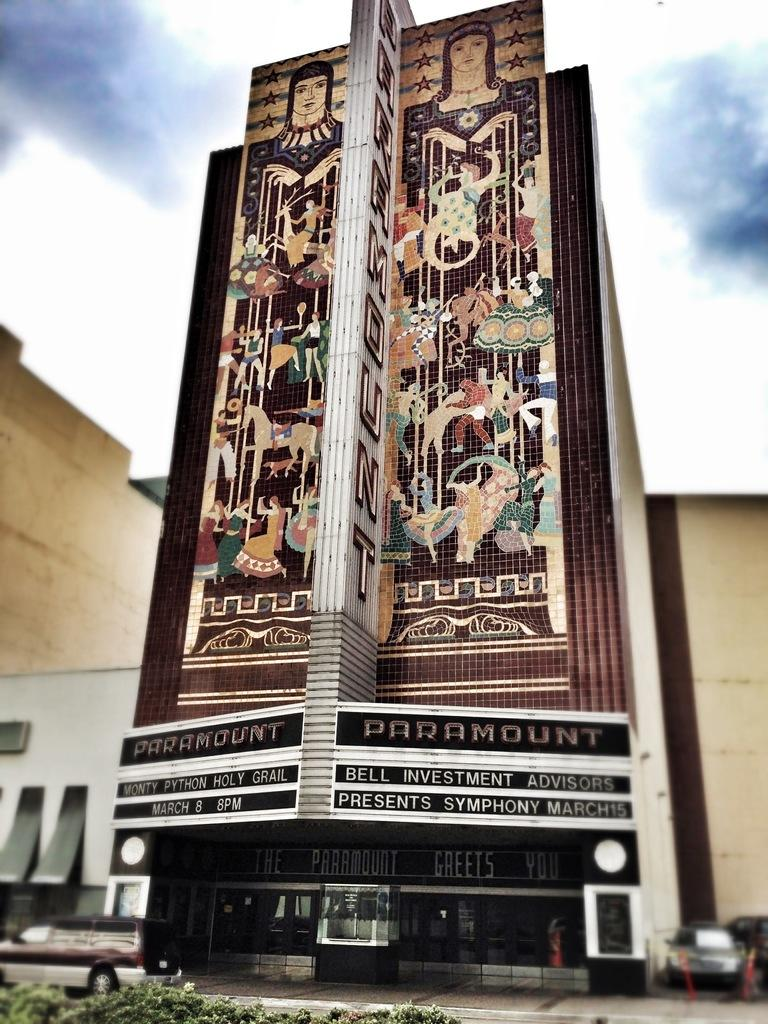What type of structures can be seen in the image? There are buildings in the image. What is located in front of the buildings? Cars are present in front of the buildings. What can be seen in the sky in the image? Clouds are visible at the top of the image. What type of collar can be seen on the car in the image? There is no collar present on any car in the image. How is the division between the buildings and the sky depicted in the image? The division between the buildings and the sky is not explicitly depicted in the image; it is implied by the presence of clouds at the top of the image. 